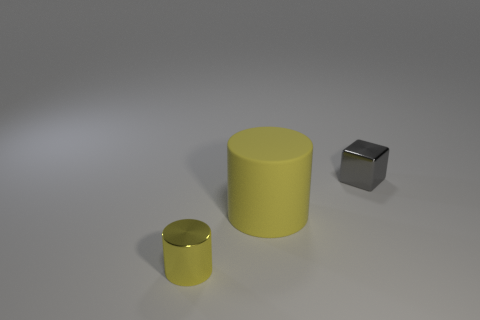Add 3 purple cylinders. How many objects exist? 6 Subtract all cylinders. How many objects are left? 1 Add 1 tiny green rubber spheres. How many tiny green rubber spheres exist? 1 Subtract 0 purple balls. How many objects are left? 3 Subtract all tiny brown spheres. Subtract all yellow things. How many objects are left? 1 Add 2 large rubber cylinders. How many large rubber cylinders are left? 3 